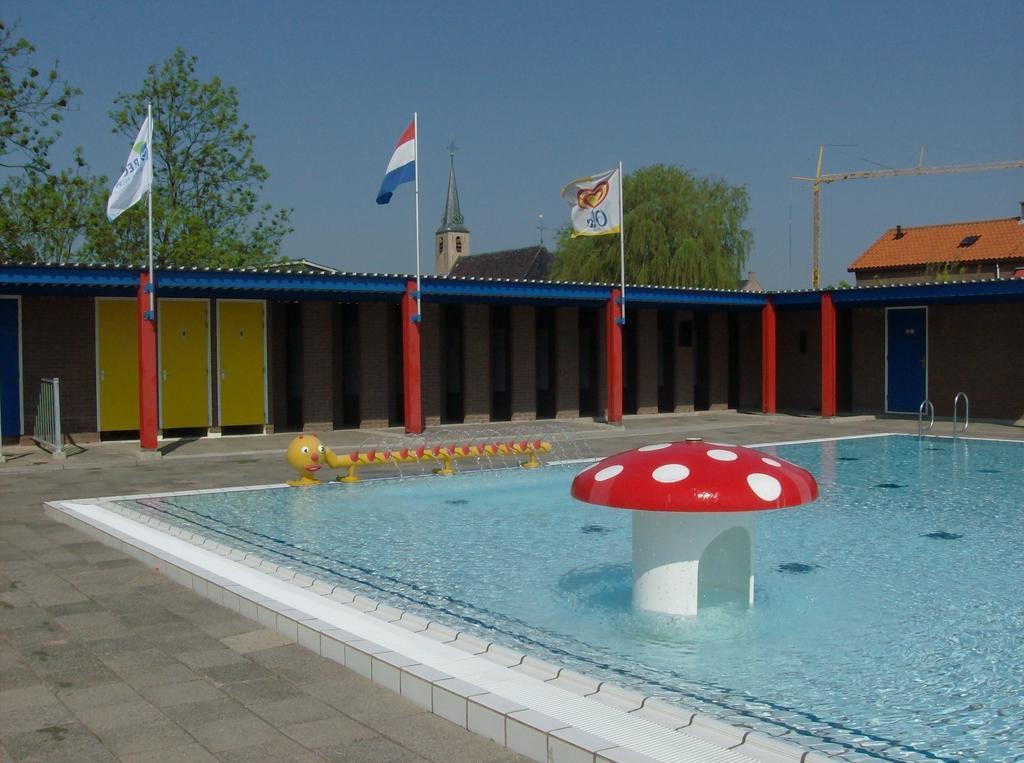Describe this image in one or two sentences. In this picture there is a swimming pool at the bottom side of the image and there are pillars, cupboards, flags, and a door in the image and there are houses and trees in the background area of the image. 